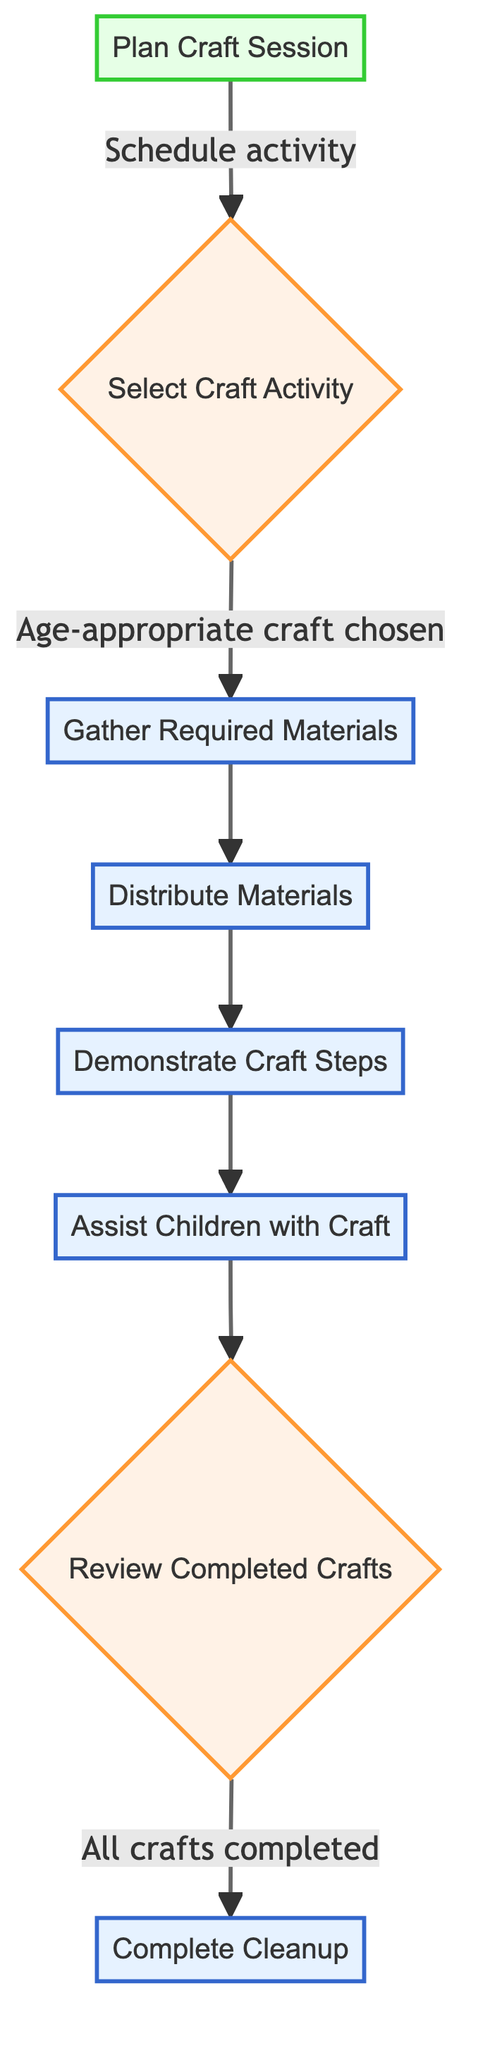What is the first step in the flowchart? The first step is represented by the node "Plan Craft Session," which serves as the starting point of the process. This can be identified as it doesn't have any incoming arrows.
Answer: Plan Craft Session How many decision nodes are present in the diagram? There are two decision nodes indicated by the diamond shapes: "Select Craft Activity" and "Review Completed Crafts." Counting these gives a total of two decision nodes.
Answer: 2 What follows the "Demonstrate Craft Steps" node? The node that comes after "Demonstrate Craft Steps" is "Assist Children with Craft," as shown by the arrow leading out of the demonstration node.
Answer: Assist Children with Craft What is required before distributing materials? The node that comes before "Distribute Materials" is "Gather Required Materials," according to the flow of the chart showing the sequence of steps leading up to distribution.
Answer: Gather Required Materials If the craft activity chosen is not age-appropriate, where does the flow go next? If the craft activity is not age-appropriate, the flow cannot proceed to the next step, "Gather Required Materials," indicating that the process may end or be redirected back to a previous state for selection.
Answer: Not possible to proceed What is the final step in the craft preparation sequence? The last step in the sequence is "Complete Cleanup," which occurs after reviewing the completed crafts, indicating the end of the process.
Answer: Complete Cleanup Which step involves evaluating completed crafts? The step that involves evaluating completed crafts is called "Review Completed Crafts." This decision node assesses whether all crafts have been completed by the children.
Answer: Review Completed Crafts List all the process nodes in order from the beginning. The process nodes in order starting from the beginning are: "Plan Craft Session," "Gather Required Materials," "Distribute Materials," "Demonstrate Craft Steps," "Assist Children with Craft," and "Complete Cleanup." This sequence is traced through the arrows connecting the nodes in the diagram.
Answer: Plan Craft Session, Gather Required Materials, Distribute Materials, Demonstrate Craft Steps, Assist Children with Craft, Complete Cleanup What action takes place after all crafts are completed? After confirming that all crafts are completed, the action that follows is "Complete Cleanup," indicating the finalization of the craft activity process.
Answer: Complete Cleanup 